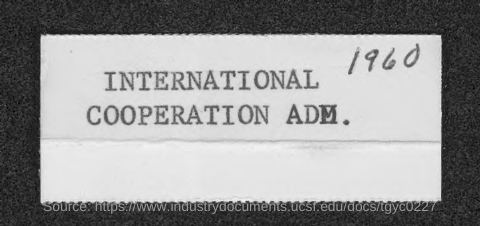Mention the year shown in the document?
Make the answer very short. 1960. 